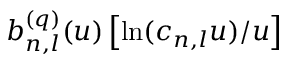<formula> <loc_0><loc_0><loc_500><loc_500>b _ { n , l } ^ { ( q ) } ( u ) \left [ \ln ( c _ { n , l } u ) / u \right ]</formula> 